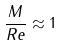Convert formula to latex. <formula><loc_0><loc_0><loc_500><loc_500>\frac { M } { R e } \approx 1</formula> 